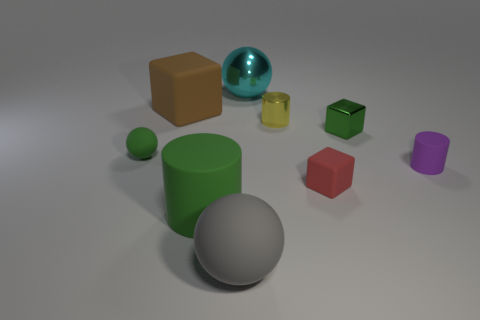Subtract all purple cylinders. How many cylinders are left? 2 Subtract 1 cylinders. How many cylinders are left? 2 Add 1 green cylinders. How many objects exist? 10 Subtract all balls. How many objects are left? 6 Subtract all red objects. Subtract all matte cylinders. How many objects are left? 6 Add 3 green objects. How many green objects are left? 6 Add 6 tiny green metallic things. How many tiny green metallic things exist? 7 Subtract 1 green blocks. How many objects are left? 8 